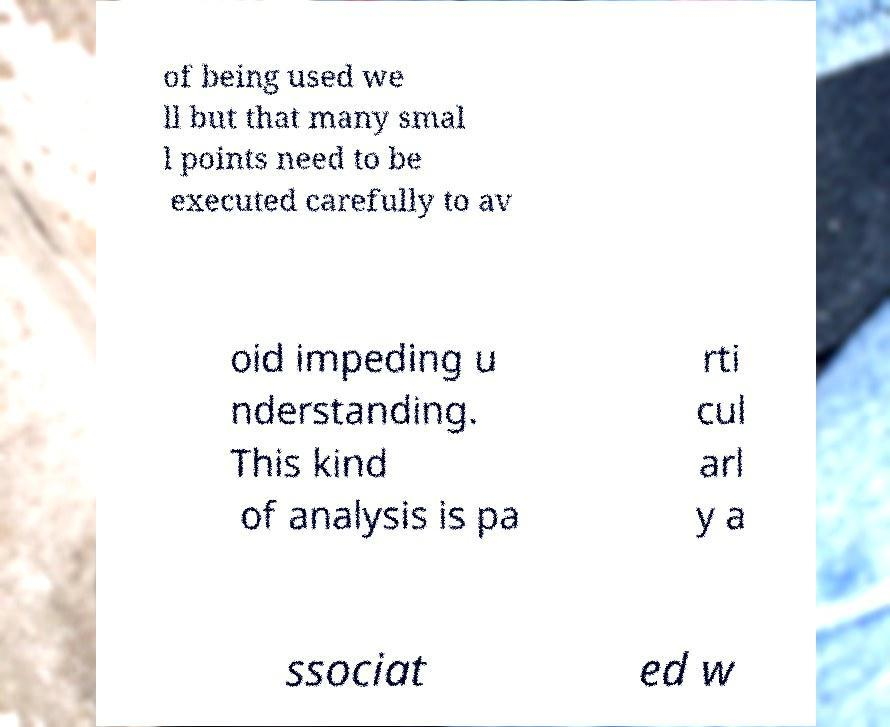There's text embedded in this image that I need extracted. Can you transcribe it verbatim? of being used we ll but that many smal l points need to be executed carefully to av oid impeding u nderstanding. This kind of analysis is pa rti cul arl y a ssociat ed w 